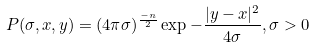<formula> <loc_0><loc_0><loc_500><loc_500>P ( \sigma , x , y ) = ( 4 \pi \sigma ) ^ { \frac { - n } { 2 } } \exp - \frac { | y - x | ^ { 2 } } { 4 \sigma } , \sigma > 0</formula> 